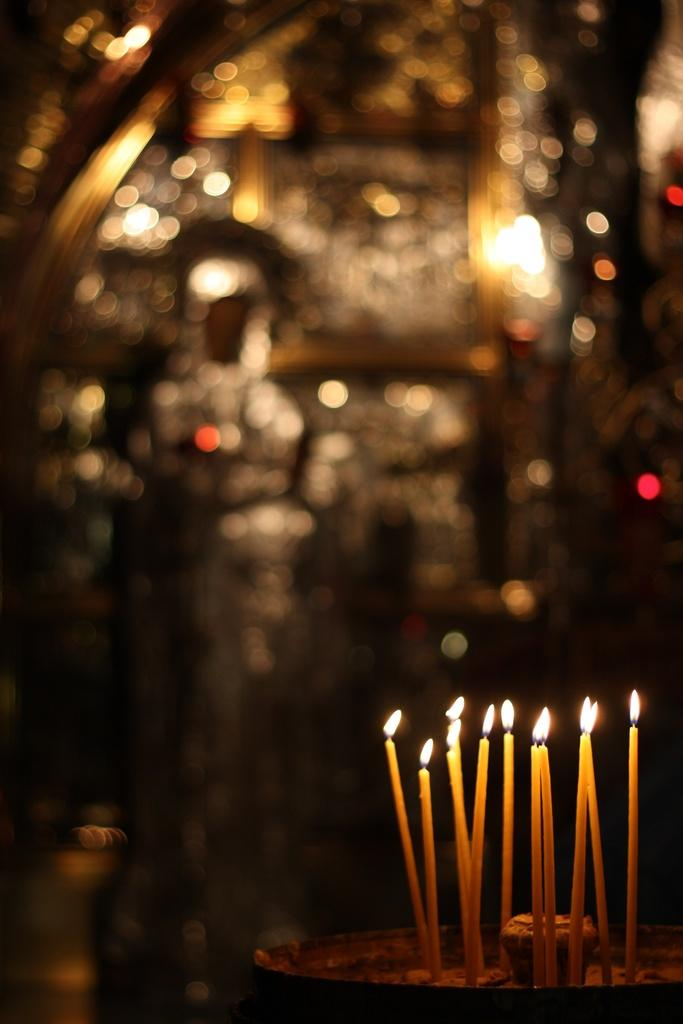What is present in the image that is producing light? There are candles with flames in the image. What are the candles resting on? The candles are on an object. Can you describe the background of the image? The background of the image is blurred. What industry is being represented by the candles in the image? There is no specific industry represented by the candles in the image; they are simply candles with flames. 